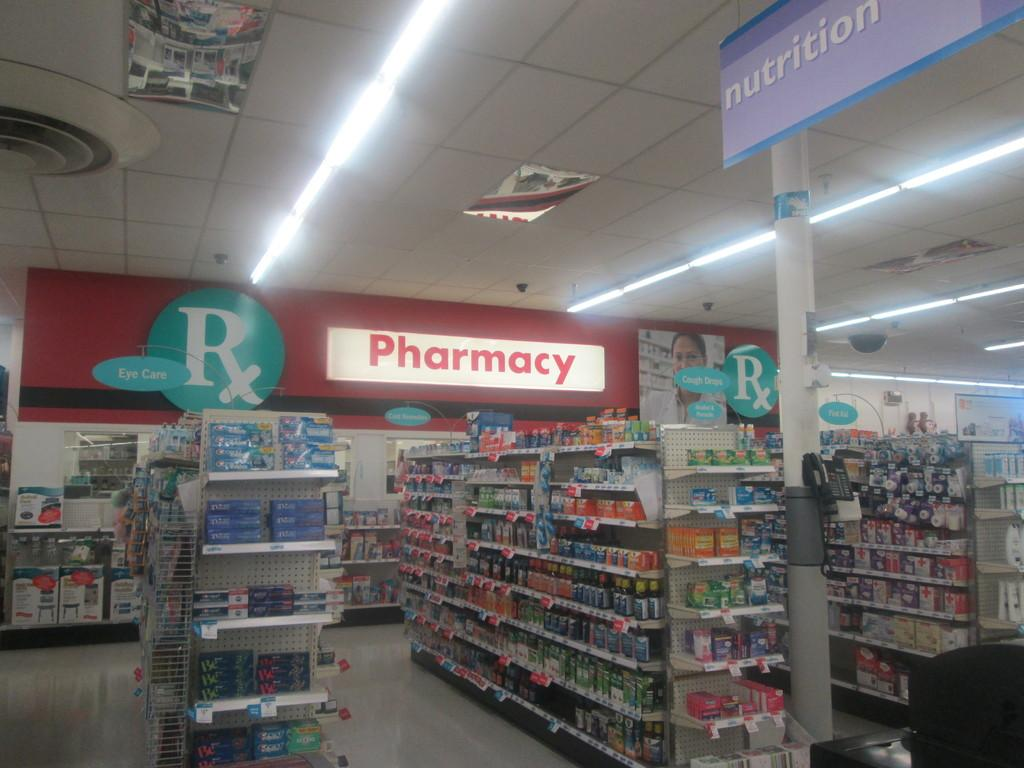<image>
Describe the image concisely. an inside view of a Pharmacy and various shelves of goods 